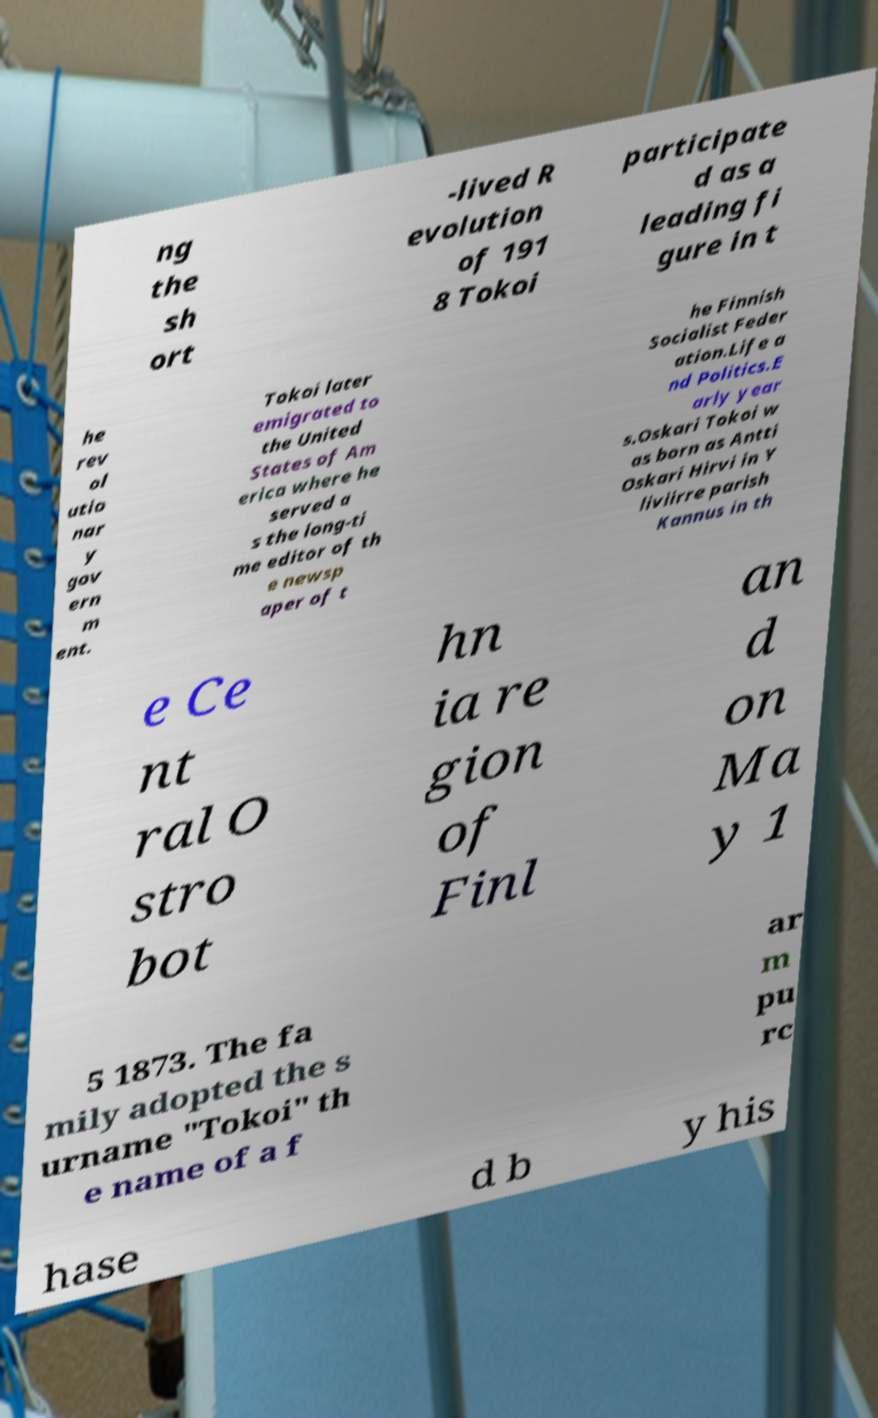Could you extract and type out the text from this image? ng the sh ort -lived R evolution of 191 8 Tokoi participate d as a leading fi gure in t he rev ol utio nar y gov ern m ent. Tokoi later emigrated to the United States of Am erica where he served a s the long-ti me editor of th e newsp aper of t he Finnish Socialist Feder ation.Life a nd Politics.E arly year s.Oskari Tokoi w as born as Antti Oskari Hirvi in Y liviirre parish Kannus in th e Ce nt ral O stro bot hn ia re gion of Finl an d on Ma y 1 5 1873. The fa mily adopted the s urname "Tokoi" th e name of a f ar m pu rc hase d b y his 